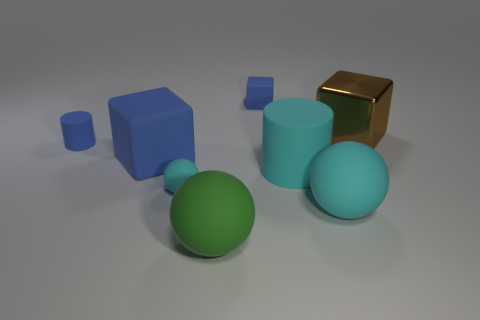Add 2 green balls. How many objects exist? 10 Subtract all cubes. How many objects are left? 5 Subtract all tiny green matte cubes. Subtract all small matte things. How many objects are left? 5 Add 3 small cyan spheres. How many small cyan spheres are left? 4 Add 8 large red rubber spheres. How many large red rubber spheres exist? 8 Subtract 0 gray balls. How many objects are left? 8 